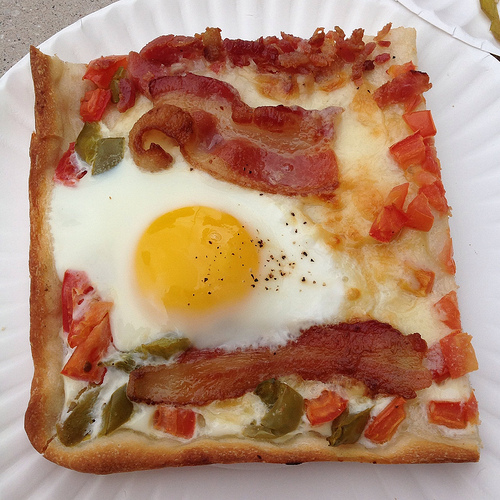Please provide a short description for this region: [0.57, 0.13, 0.82, 0.54]. This region showcases enticing melted cheese generously layered over crispy bread, a key component adding texture and richness to the breakfast pizza. 